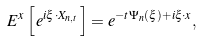<formula> <loc_0><loc_0><loc_500><loc_500>E ^ { x } \left [ \, e ^ { i \xi \cdot X _ { n , t } } \, \right ] = e ^ { - t \Psi _ { n } ( \xi ) + i \xi \cdot x } ,</formula> 